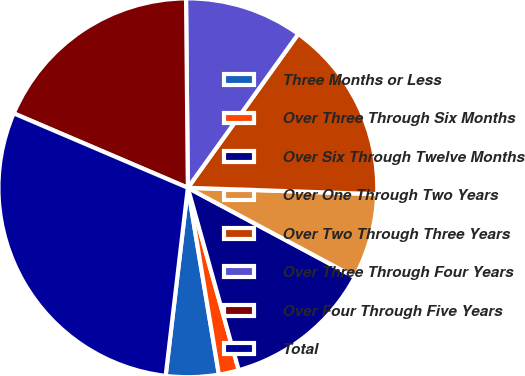Convert chart to OTSL. <chart><loc_0><loc_0><loc_500><loc_500><pie_chart><fcel>Three Months or Less<fcel>Over Three Through Six Months<fcel>Over Six Through Twelve Months<fcel>Over One Through Two Years<fcel>Over Two Through Three Years<fcel>Over Three Through Four Years<fcel>Over Four Through Five Years<fcel>Total<nl><fcel>4.49%<fcel>1.71%<fcel>12.85%<fcel>7.28%<fcel>15.63%<fcel>10.06%<fcel>18.42%<fcel>29.56%<nl></chart> 